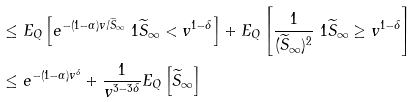Convert formula to latex. <formula><loc_0><loc_0><loc_500><loc_500>& \leq E _ { Q } \left [ e ^ { - ( 1 - \alpha ) v / \widetilde { S } _ { \infty } } \ 1 { \widetilde { S } _ { \infty } < v ^ { 1 - \delta } } \right ] + E _ { Q } \left [ \frac { 1 } { ( \widetilde { S } _ { \infty } ) ^ { 2 } } \ 1 { \widetilde { S } _ { \infty } \geq v ^ { 1 - \delta } } \right ] \\ & \leq e ^ { - ( 1 - \alpha ) v ^ { \delta } } + \frac { 1 } { v ^ { 3 - 3 \delta } } E _ { Q } \left [ \widetilde { S } _ { \infty } \right ]</formula> 